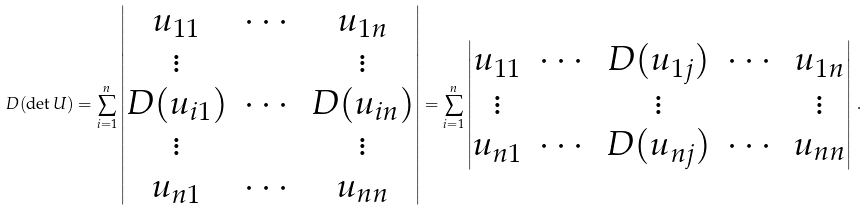Convert formula to latex. <formula><loc_0><loc_0><loc_500><loc_500>D ( \det U ) = \sum _ { i = 1 } ^ { n } \left | \begin{matrix} u _ { 1 1 } & \cdots & u _ { 1 n } \\ \vdots & & \vdots \\ D ( u _ { i 1 } ) & \cdots & D ( u _ { i n } ) \\ \vdots & & \vdots \\ u _ { n 1 } & \cdots & u _ { n n } \end{matrix} \right | = \sum _ { i = 1 } ^ { n } \left | \begin{matrix} u _ { 1 1 } & \cdots & D ( u _ { 1 j } ) & \cdots & u _ { 1 n } \\ \vdots & & \vdots & & \vdots \\ u _ { n 1 } & \cdots & D ( u _ { n j } ) & \cdots & u _ { n n } \end{matrix} \right | \, .</formula> 